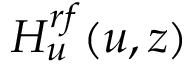<formula> <loc_0><loc_0><loc_500><loc_500>H _ { u } ^ { r f } ( u , z )</formula> 